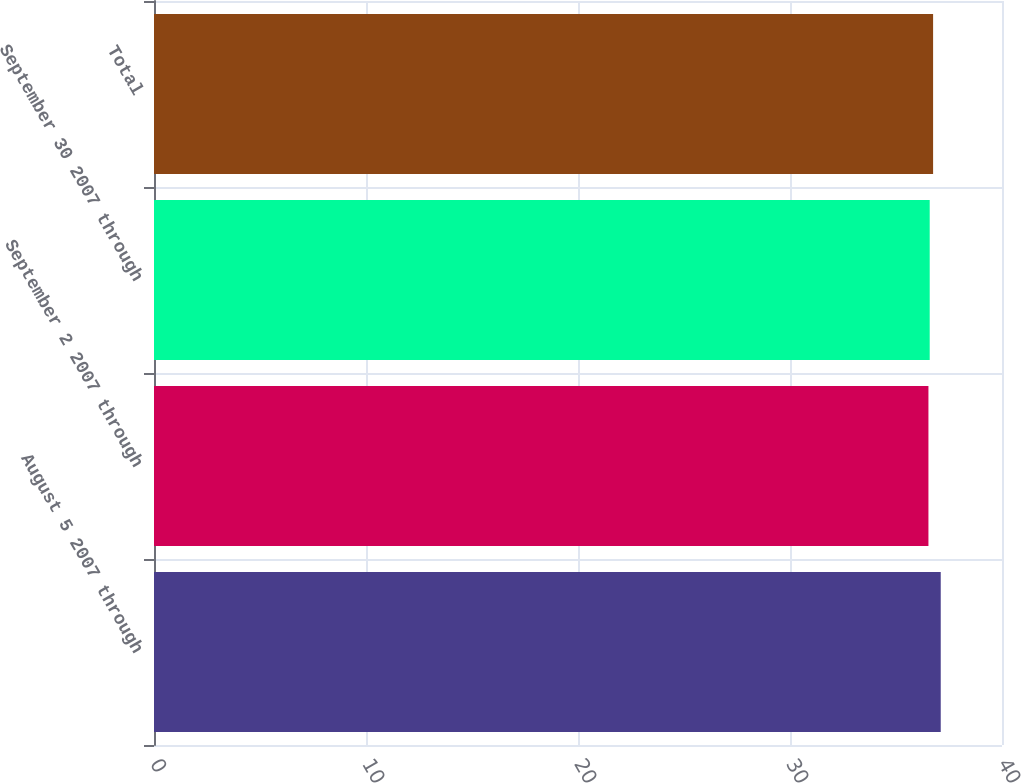Convert chart to OTSL. <chart><loc_0><loc_0><loc_500><loc_500><bar_chart><fcel>August 5 2007 through<fcel>September 2 2007 through<fcel>September 30 2007 through<fcel>Total<nl><fcel>37.11<fcel>36.53<fcel>36.59<fcel>36.75<nl></chart> 